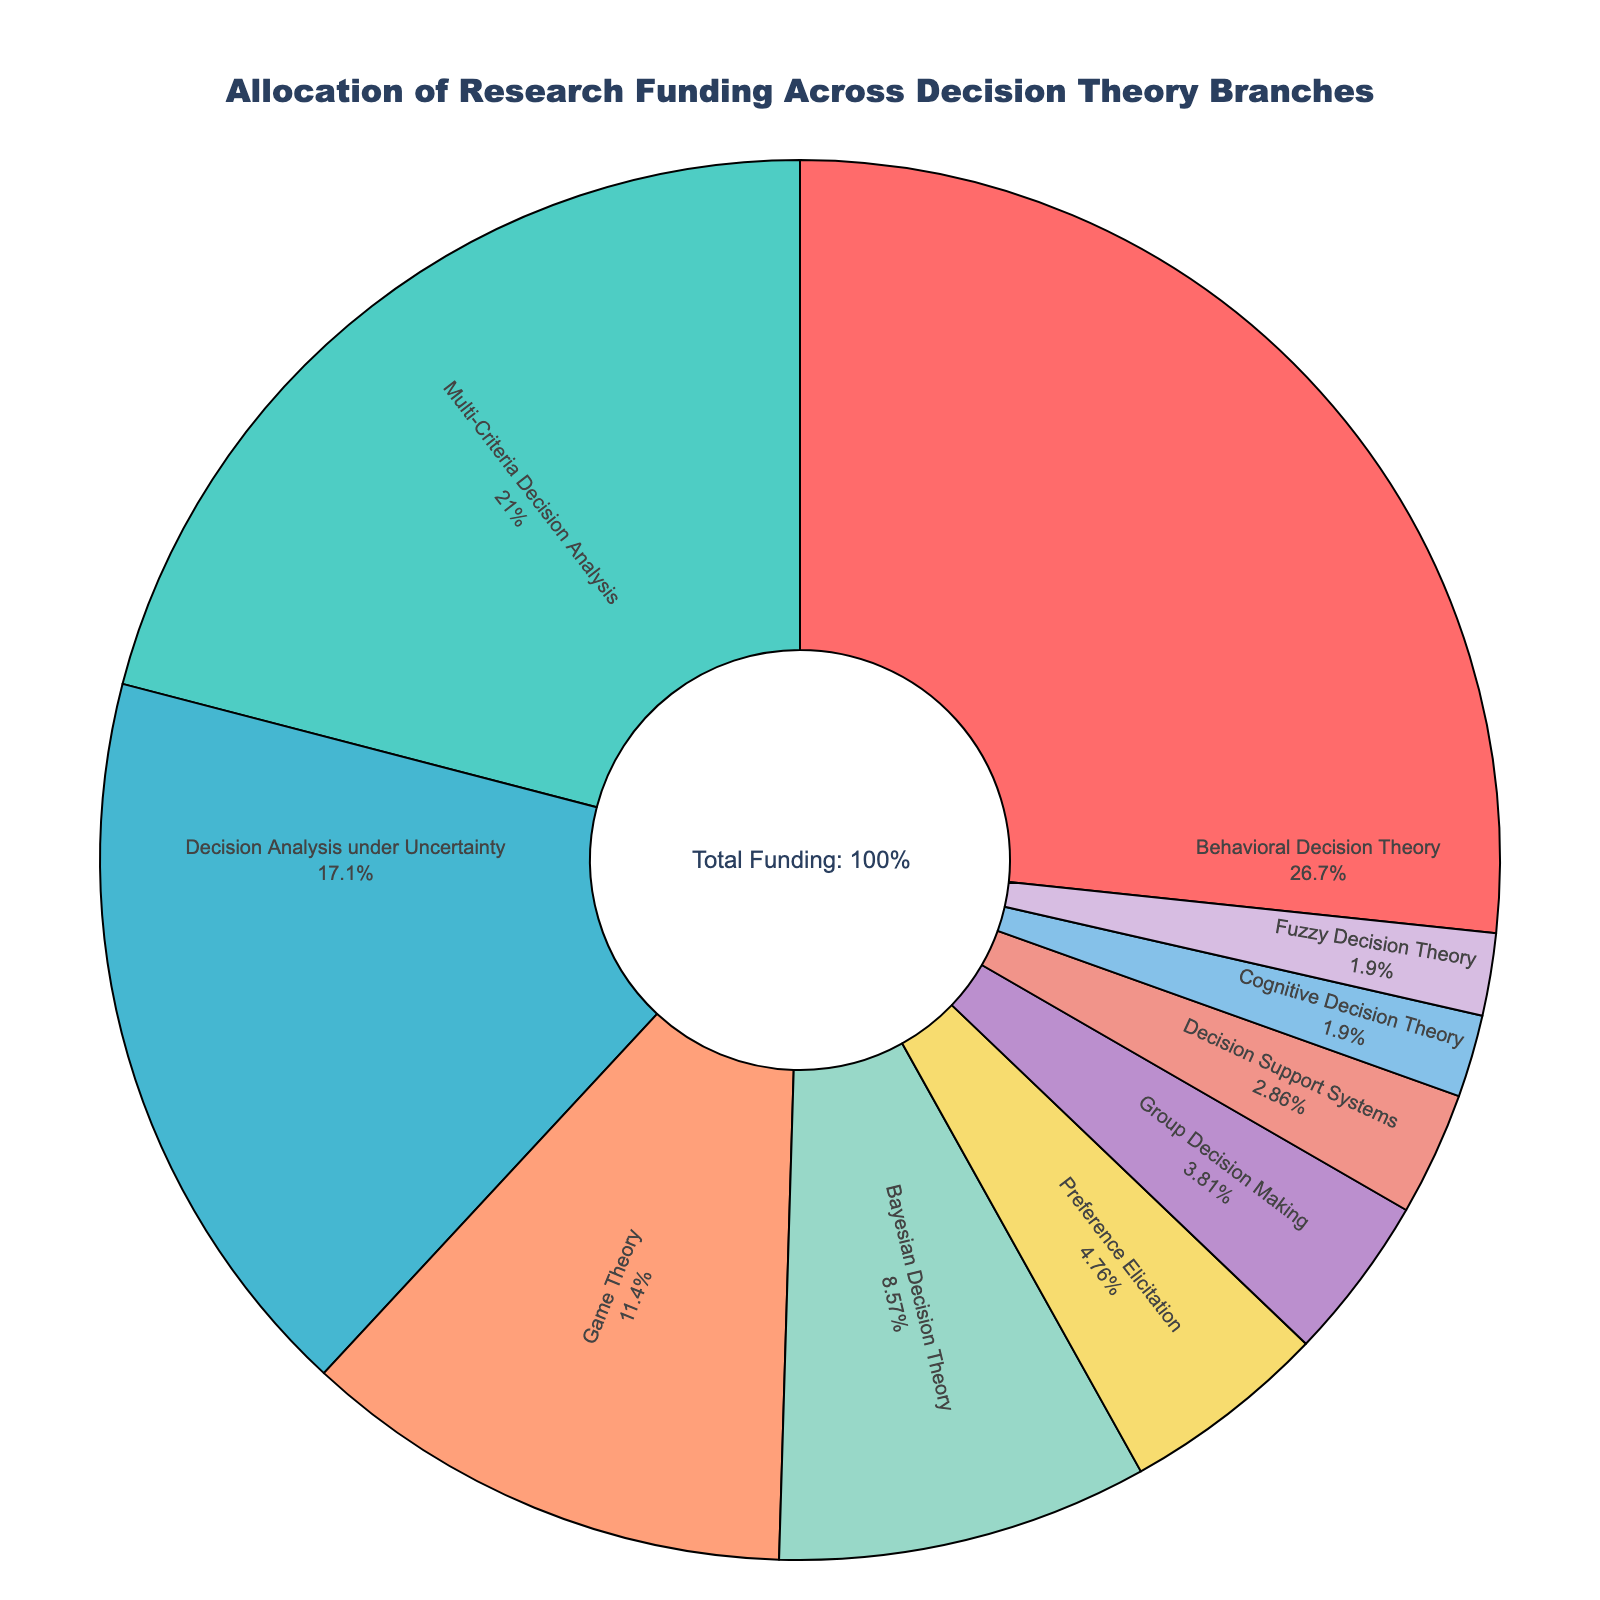What percentage of the funding is allocated to 'Behavioral Decision Theory'? The pie chart shows the funding allocation for each branch of Decision Theory. 'Behavioral Decision Theory' has a funding percentage of 28%.
Answer: 28% What is the total funding percentage for 'Game Theory' and 'Bayesian Decision Theory' combined? According to the pie chart, 'Game Theory' has 12% and 'Bayesian Decision Theory' has 9%. The combined funding is calculated as 12% + 9% = 21%.
Answer: 21% Which branch has the least amount of funding allocated, and what is that percentage? The pie chart shows that both 'Cognitive Decision Theory' and 'Fuzzy Decision Theory' have the least funding, each with 2%.
Answer: Cognitive Decision Theory and Fuzzy Decision Theory with 2% What is the difference between the funding percentages of 'Multi-Criteria Decision Analysis' and 'Decision Analysis under Uncertainty'? The pie chart indicates that 'Multi-Criteria Decision Analysis' is allocated 22% and 'Decision Analysis under Uncertainty' 18%. The difference is 22% - 18%, which equals 4%.
Answer: 4% Which branch has more funding: 'Group Decision Making' or 'Decision Support Systems'? According to the pie chart, 'Group Decision Making' has 4%, whereas 'Decision Support Systems' has 3%. Therefore, 'Group Decision Making' has more funding.
Answer: Group Decision Making How much more funding does 'Behavioral Decision Theory' receive compared to 'Preference Elicitation'? 'Behavioral Decision Theory' has 28% funding and 'Preference Elicitation' has 5%. The difference is calculated as 28% - 5% = 23%.
Answer: 23% What is the combined percentage of funding allocated to branches with less than 10% funding each? The branches with less than 10% funding are 'Bayesian Decision Theory' (9%), 'Preference Elicitation' (5%), 'Group Decision Making' (4%), 'Decision Support Systems' (3%), 'Cognitive Decision Theory' (2%), and 'Fuzzy Decision Theory' (2%). Summing these, 9% + 5% + 4% + 3% + 2% + 2% = 25%.
Answer: 25% Which segment in the pie chart appears the largest, and what is the corresponding branch? The largest segment in the pie chart corresponds to 'Behavioral Decision Theory', which has 28% of the funding.
Answer: Behavioral Decision Theory What's the funding difference between the top-funded and least-funded branches? 'Behavioral Decision Theory' has the highest funding at 28%, and both 'Cognitive Decision Theory' and 'Fuzzy Decision Theory' have the lowest at 2%. The difference is 28% - 2% = 26%.
Answer: 26% If the funding for 'Decision Analysis under Uncertainty' were to increase by 5 percentage points, what would the new total funding percentage for this branch be? Currently, 'Decision Analysis under Uncertainty' has 18% funding. If it increases by 5 percentage points, the new funding would be 18% + 5% = 23%.
Answer: 23% 